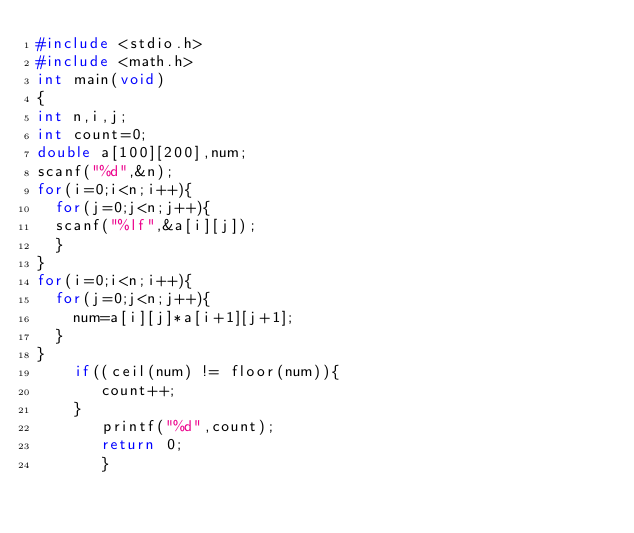Convert code to text. <code><loc_0><loc_0><loc_500><loc_500><_C_>#include <stdio.h>
#include <math.h>
int main(void)
{
int n,i,j;
int count=0;
double a[100][200],num;
scanf("%d",&n);
for(i=0;i<n;i++){
  for(j=0;j<n;j++){
  scanf("%lf",&a[i][j]);
  }
}
for(i=0;i<n;i++){
  for(j=0;j<n;j++){
    num=a[i][j]*a[i+1][j+1];
  }
}
    if((ceil(num) != floor(num)){
       count++;
    }
       printf("%d",count);
       return 0;
       }
    
  
  
</code> 